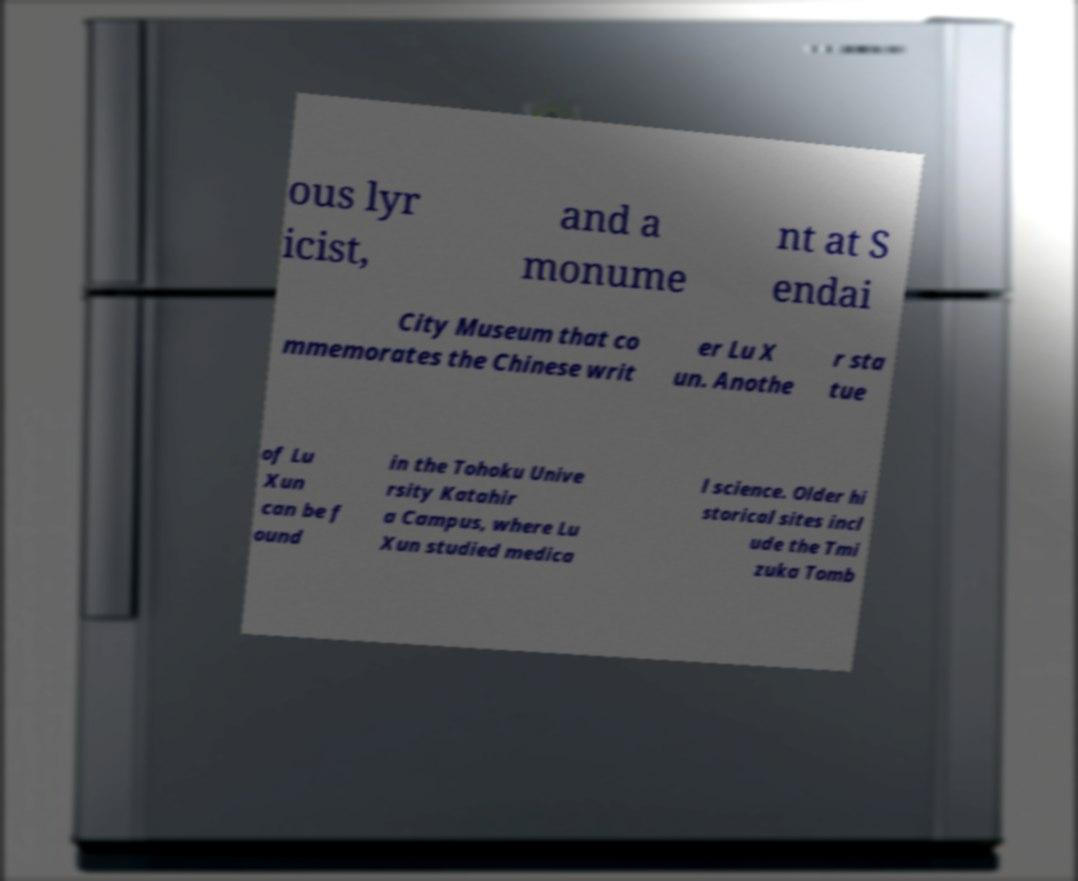Could you assist in decoding the text presented in this image and type it out clearly? ous lyr icist, and a monume nt at S endai City Museum that co mmemorates the Chinese writ er Lu X un. Anothe r sta tue of Lu Xun can be f ound in the Tohoku Unive rsity Katahir a Campus, where Lu Xun studied medica l science. Older hi storical sites incl ude the Tmi zuka Tomb 